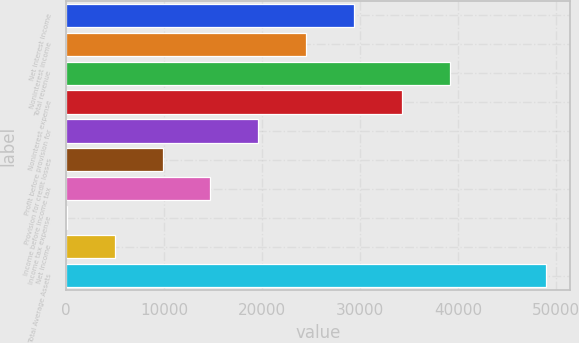<chart> <loc_0><loc_0><loc_500><loc_500><bar_chart><fcel>Net interest income<fcel>Noninterest income<fcel>Total revenue<fcel>Noninterest expense<fcel>Profit before provision for<fcel>Provision for credit losses<fcel>Income before income tax<fcel>Income tax expense<fcel>Net income<fcel>Total Average Assets<nl><fcel>29401.8<fcel>24517.5<fcel>39170.4<fcel>34286.1<fcel>19633.2<fcel>9864.6<fcel>14748.9<fcel>96<fcel>4980.3<fcel>48939<nl></chart> 